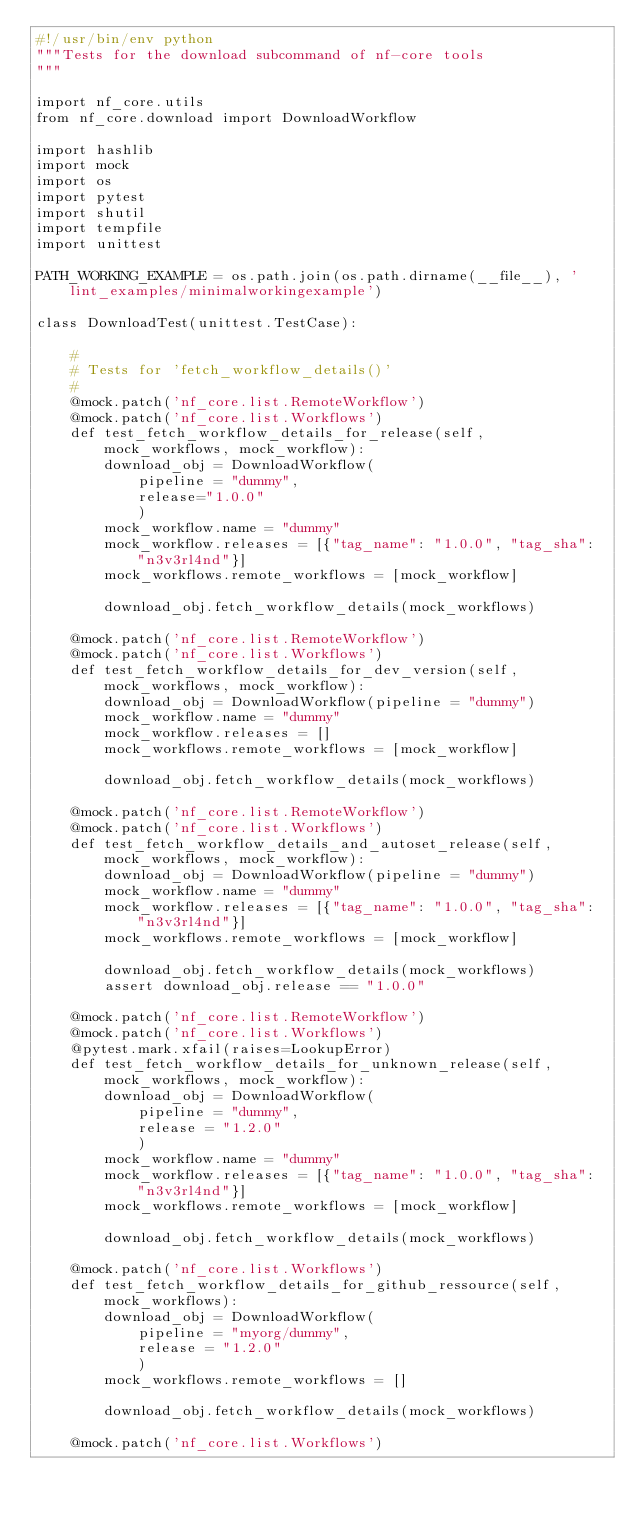<code> <loc_0><loc_0><loc_500><loc_500><_Python_>#!/usr/bin/env python
"""Tests for the download subcommand of nf-core tools
"""

import nf_core.utils
from nf_core.download import DownloadWorkflow

import hashlib
import mock
import os
import pytest
import shutil
import tempfile
import unittest

PATH_WORKING_EXAMPLE = os.path.join(os.path.dirname(__file__), 'lint_examples/minimalworkingexample')

class DownloadTest(unittest.TestCase):

    #
    # Tests for 'fetch_workflow_details()'
    #
    @mock.patch('nf_core.list.RemoteWorkflow')
    @mock.patch('nf_core.list.Workflows')
    def test_fetch_workflow_details_for_release(self, mock_workflows, mock_workflow):
        download_obj = DownloadWorkflow(
            pipeline = "dummy",
            release="1.0.0"
            )
        mock_workflow.name = "dummy"
        mock_workflow.releases = [{"tag_name": "1.0.0", "tag_sha": "n3v3rl4nd"}]
        mock_workflows.remote_workflows = [mock_workflow]

        download_obj.fetch_workflow_details(mock_workflows)

    @mock.patch('nf_core.list.RemoteWorkflow')
    @mock.patch('nf_core.list.Workflows')
    def test_fetch_workflow_details_for_dev_version(self, mock_workflows, mock_workflow):
        download_obj = DownloadWorkflow(pipeline = "dummy")
        mock_workflow.name = "dummy"
        mock_workflow.releases = []
        mock_workflows.remote_workflows = [mock_workflow]

        download_obj.fetch_workflow_details(mock_workflows)

    @mock.patch('nf_core.list.RemoteWorkflow')
    @mock.patch('nf_core.list.Workflows')
    def test_fetch_workflow_details_and_autoset_release(self, mock_workflows, mock_workflow):
        download_obj = DownloadWorkflow(pipeline = "dummy")
        mock_workflow.name = "dummy"
        mock_workflow.releases = [{"tag_name": "1.0.0", "tag_sha": "n3v3rl4nd"}]
        mock_workflows.remote_workflows = [mock_workflow]

        download_obj.fetch_workflow_details(mock_workflows)
        assert download_obj.release == "1.0.0"

    @mock.patch('nf_core.list.RemoteWorkflow')
    @mock.patch('nf_core.list.Workflows')
    @pytest.mark.xfail(raises=LookupError)
    def test_fetch_workflow_details_for_unknown_release(self, mock_workflows, mock_workflow):
        download_obj = DownloadWorkflow(
            pipeline = "dummy",
            release = "1.2.0"
            )
        mock_workflow.name = "dummy"
        mock_workflow.releases = [{"tag_name": "1.0.0", "tag_sha": "n3v3rl4nd"}]
        mock_workflows.remote_workflows = [mock_workflow]

        download_obj.fetch_workflow_details(mock_workflows)

    @mock.patch('nf_core.list.Workflows')
    def test_fetch_workflow_details_for_github_ressource(self, mock_workflows):
        download_obj = DownloadWorkflow(
            pipeline = "myorg/dummy",
            release = "1.2.0"
            )
        mock_workflows.remote_workflows = []

        download_obj.fetch_workflow_details(mock_workflows)

    @mock.patch('nf_core.list.Workflows')</code> 